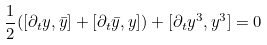Convert formula to latex. <formula><loc_0><loc_0><loc_500><loc_500>\frac { 1 } { 2 } ( [ \partial _ { t } y , \bar { y } ] + [ \partial _ { t } \bar { y } , y ] ) + [ \partial _ { t } y ^ { 3 } , y ^ { 3 } ] = 0</formula> 